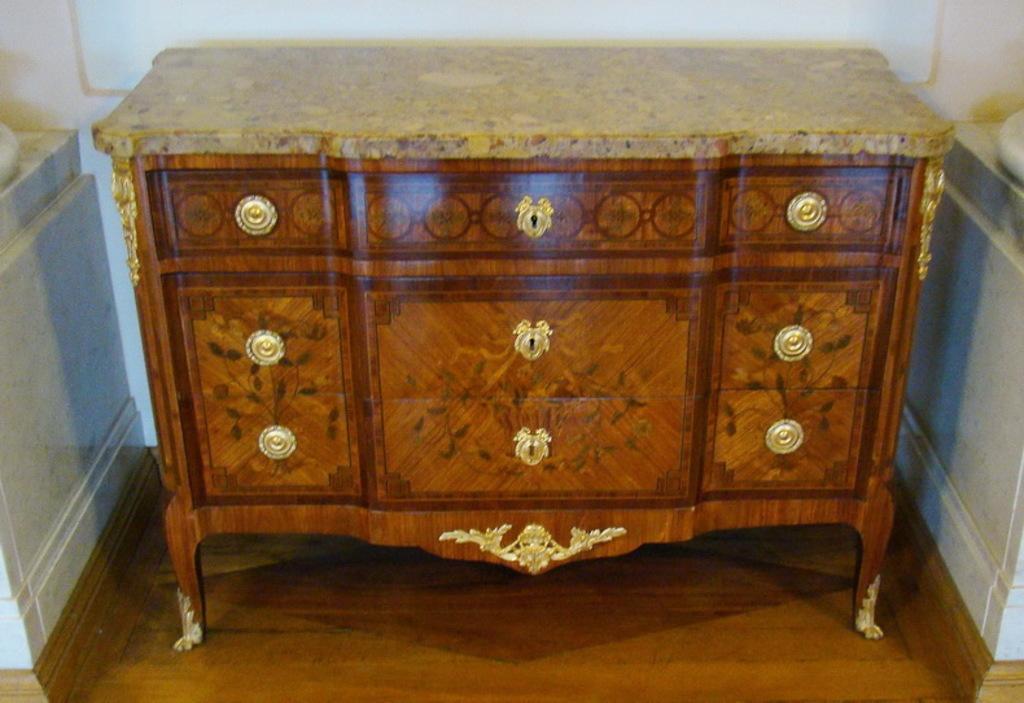Describe this image in one or two sentences. As we can see in the image there is a white color wall and brown color table. 